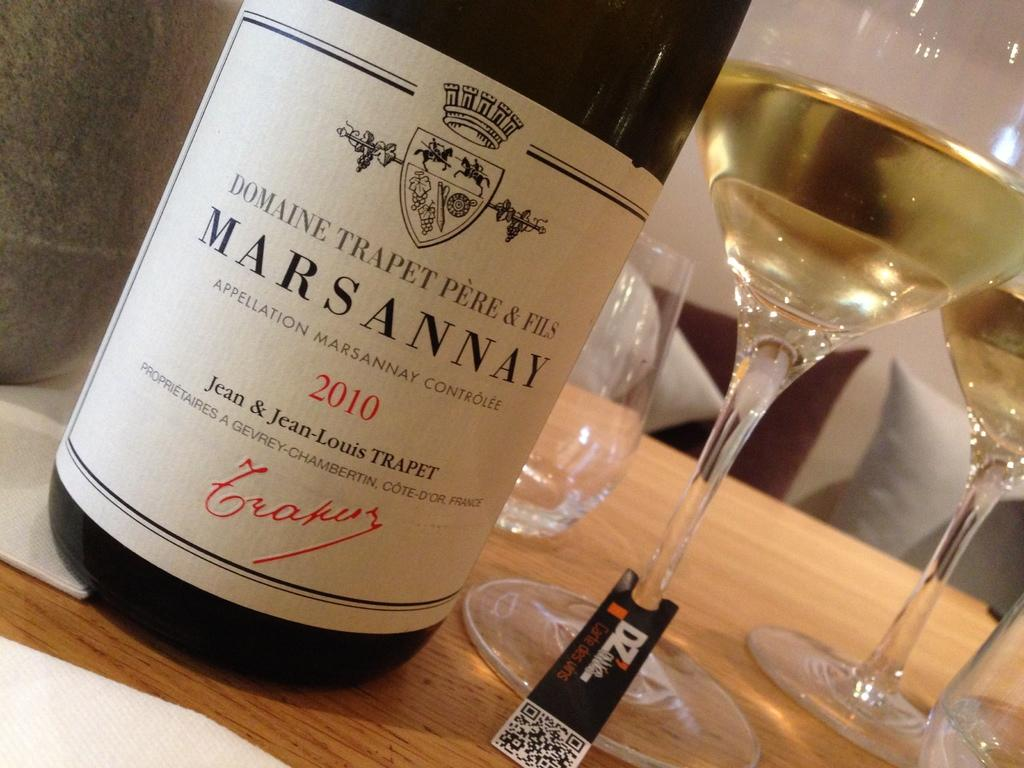What is present in the image that can hold liquid? There is a bottle in the image. What else in the image can hold liquid? There are glasses filled with liquid in the image. On what surface are the glasses placed? The glasses are placed on a wooden surface. What type of insurance is required for the bottle in the image? There is no mention of insurance in the image, and the bottle does not require any specific type of insurance. 